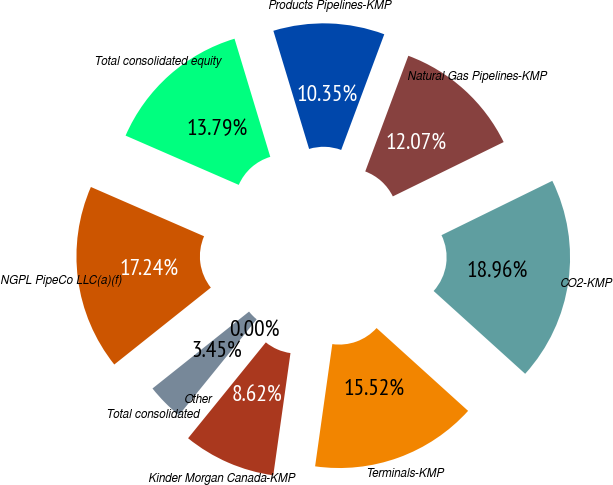<chart> <loc_0><loc_0><loc_500><loc_500><pie_chart><fcel>Products Pipelines-KMP<fcel>Natural Gas Pipelines-KMP<fcel>CO2-KMP<fcel>Terminals-KMP<fcel>Kinder Morgan Canada-KMP<fcel>Other<fcel>Total consolidated<fcel>NGPL PipeCo LLC(a)(f)<fcel>Total consolidated equity<nl><fcel>10.35%<fcel>12.07%<fcel>18.96%<fcel>15.52%<fcel>8.62%<fcel>0.0%<fcel>3.45%<fcel>17.24%<fcel>13.79%<nl></chart> 